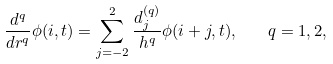<formula> <loc_0><loc_0><loc_500><loc_500>\frac { d ^ { q } } { d r ^ { q } } \phi ( i , t ) = \sum _ { j = - 2 } ^ { 2 } \frac { d _ { j } ^ { ( q ) } } { h ^ { q } } \phi ( i + j , t ) , \quad q = 1 , 2 ,</formula> 